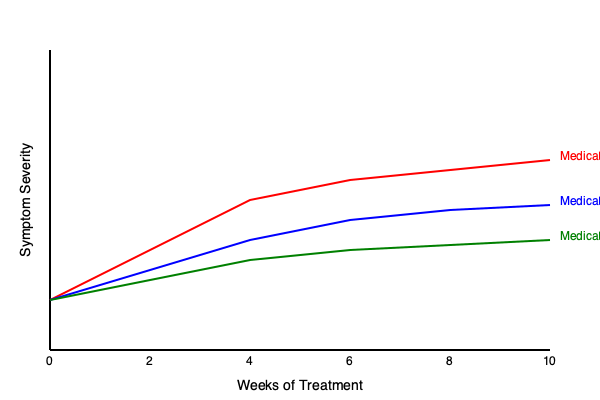Based on the multi-line graph showing symptom improvement over time for three ADHD medications, which medication appears to be the most efficacious in reducing symptom severity after 10 weeks of treatment? To determine the most efficacious medication after 10 weeks of treatment, we need to analyze the graph and compare the final symptom severity scores for each medication:

1. Identify the three medications:
   - Red line: Medication A
   - Blue line: Medication B
   - Green line: Medication C

2. Observe the trend for each medication:
   - All medications show a decrease in symptom severity over time.
   - The lines never intersect, maintaining their relative positions throughout the 10-week period.

3. Compare final symptom severity at 10 weeks (right end of the graph):
   - Medication A (red) has the lowest endpoint, indicating the lowest symptom severity.
   - Medication B (blue) has the second-lowest endpoint.
   - Medication C (green) has the highest endpoint, indicating the highest remaining symptom severity.

4. Interpret the results:
   - Lower symptom severity indicates better efficacy.
   - The medication with the lowest symptom severity at 10 weeks is the most efficacious.

5. Conclusion:
   Medication A (red line) shows the lowest symptom severity at the 10-week mark, indicating it is the most efficacious in reducing ADHD symptoms over the treatment period.
Answer: Medication A 